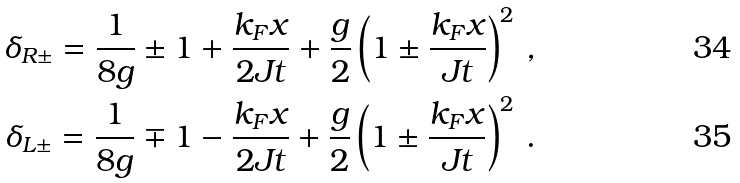<formula> <loc_0><loc_0><loc_500><loc_500>\delta _ { R \pm } = \frac { 1 } { 8 g } \pm 1 + \frac { k _ { F } x } { 2 J t } + \frac { g } { 2 } \left ( { 1 \pm \frac { k _ { F } x } { J t } } \right ) ^ { 2 } \, , \\ \delta _ { L \pm } = \frac { 1 } { 8 g } \mp 1 - \frac { k _ { F } x } { 2 J t } + \frac { g } { 2 } \left ( { 1 \pm \frac { k _ { F } x } { J t } } \right ) ^ { 2 } \, .</formula> 